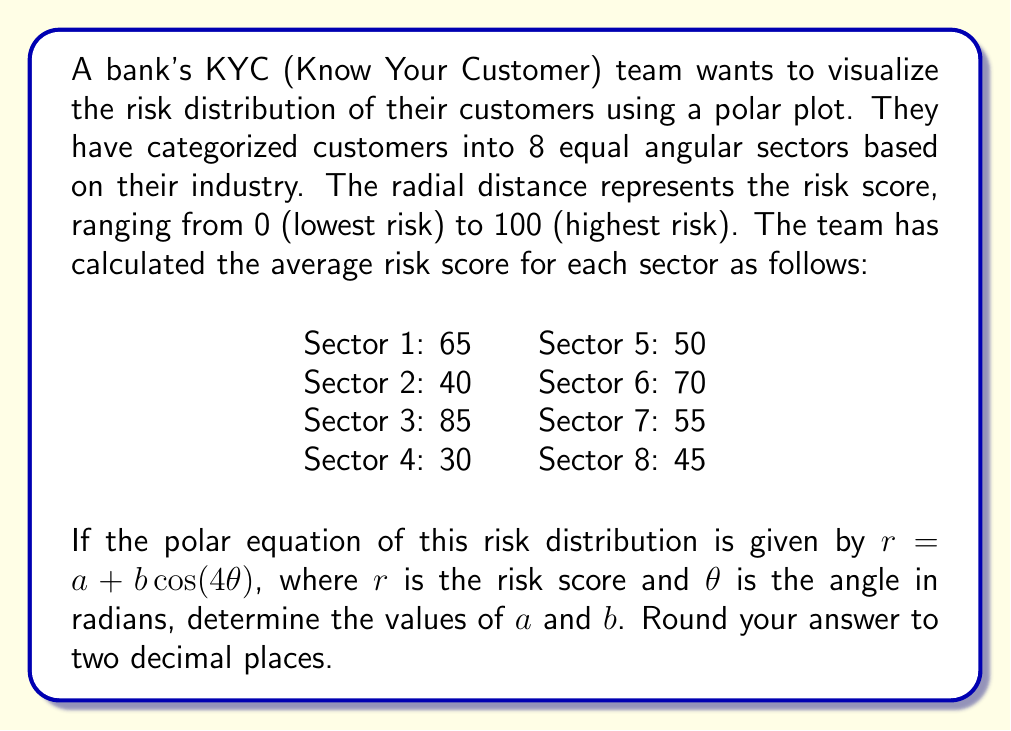Can you answer this question? To solve this problem, we'll follow these steps:

1) First, we need to understand that the equation $r = a + b\cos(4\theta)$ represents a four-leafed rose in polar coordinates. The parameter $a$ represents the average radius, while $b$ determines the amplitude of the oscillation around this average.

2) To find $a$, we calculate the average of all risk scores:

   $a = \frac{65 + 40 + 85 + 30 + 50 + 70 + 55 + 45}{8} = \frac{440}{8} = 55$

3) Now, we need to find $b$. We can do this by considering the maximum and minimum values of the cosine function:
   
   When $\cos(4\theta) = 1$, $r = a + b$
   When $\cos(4\theta) = -1$, $r = a - b$

4) The maximum risk score is 85, and the minimum is 30. So we can write:

   $85 = 55 + b$
   $30 = 55 - b$

5) From the first equation:
   $b = 85 - 55 = 30$

6) We can verify this using the second equation:
   $30 = 55 - 30$, which is true.

7) Therefore, the polar equation of the risk distribution is:

   $r = 55 + 30\cos(4\theta)$

8) Rounding to two decimal places:
   $a = 55.00$
   $b = 30.00$
Answer: $a = 55.00$, $b = 30.00$ 